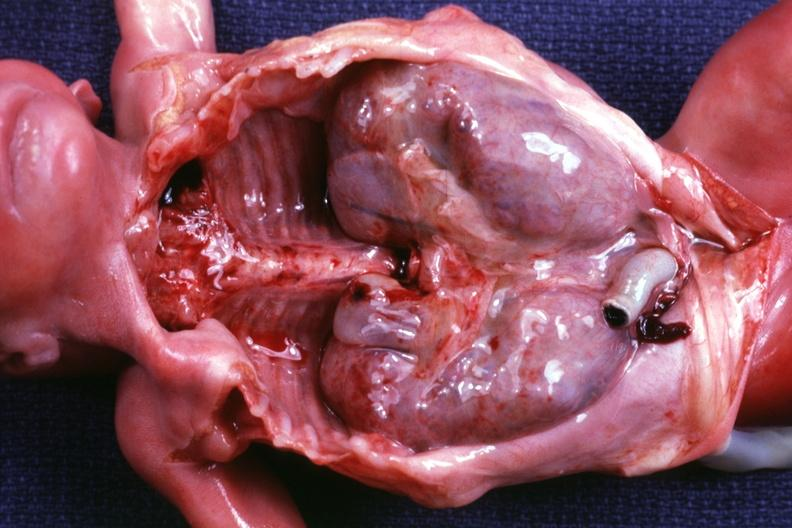where is this?
Answer the question using a single word or phrase. Urinary 